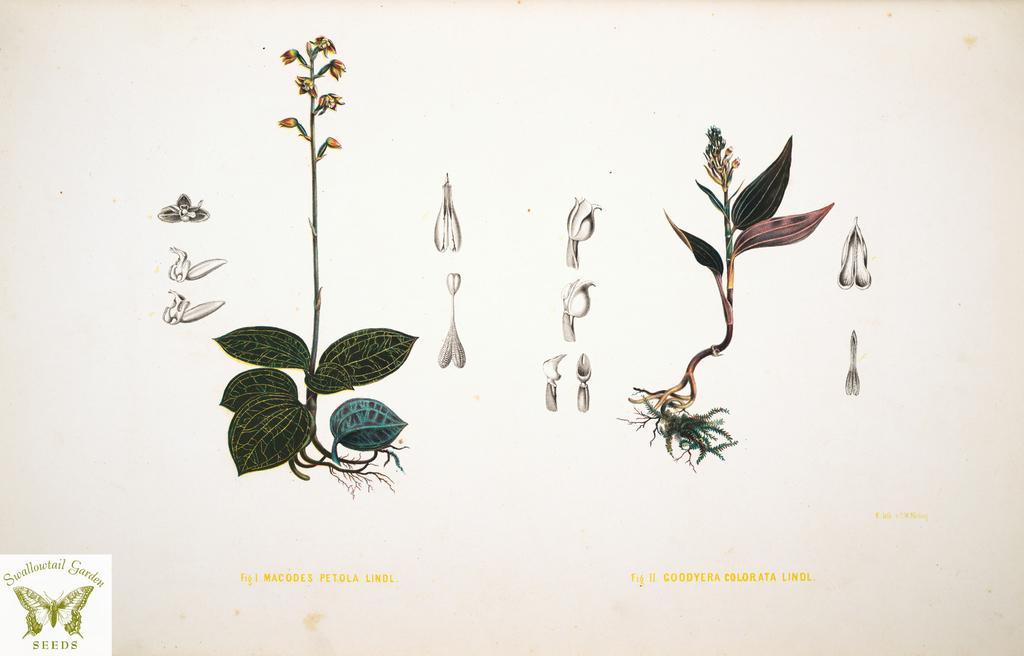Describe this image in one or two sentences. In this picture we can see the plants parts drawing on the white paper. On the left bottom side there is a butterfly watermark. 